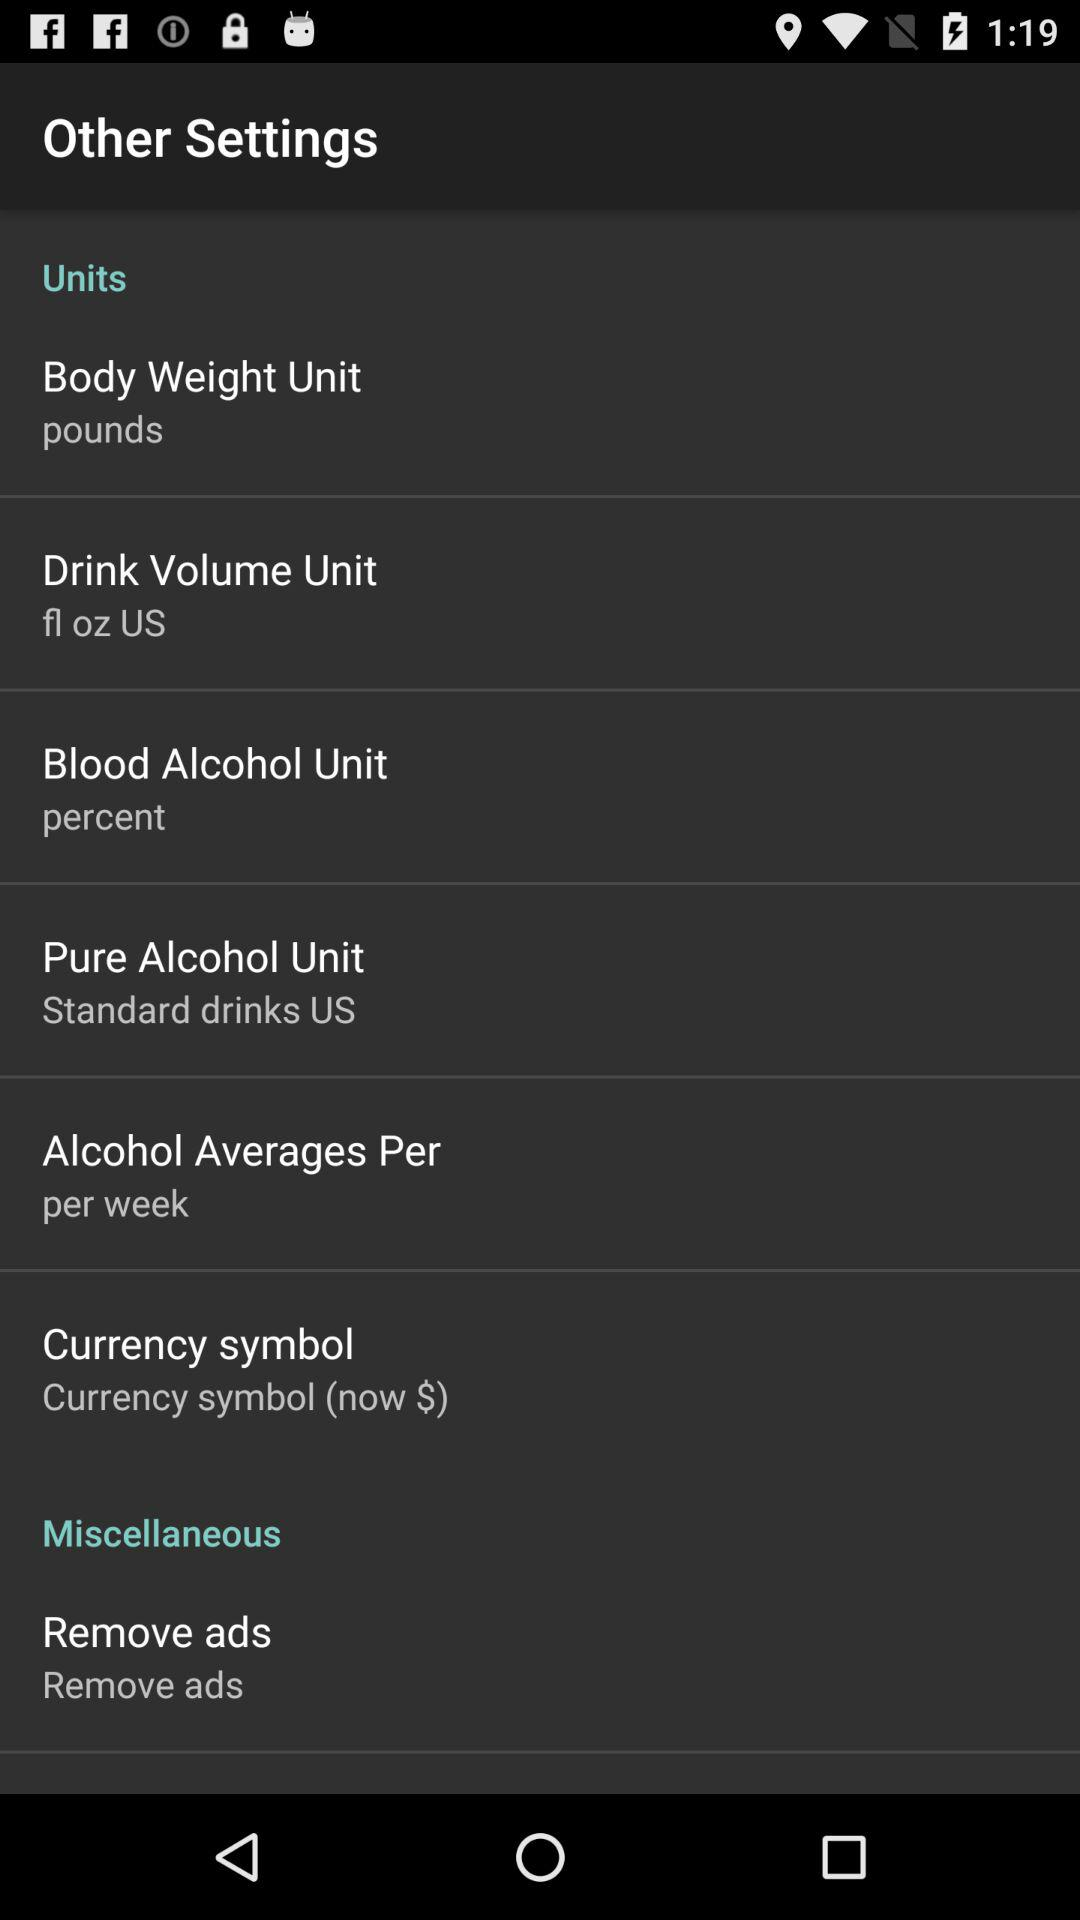What is the setting for "Alcohol Averages Per"? The setting for "Alcohol Averages Per" is "per week". 